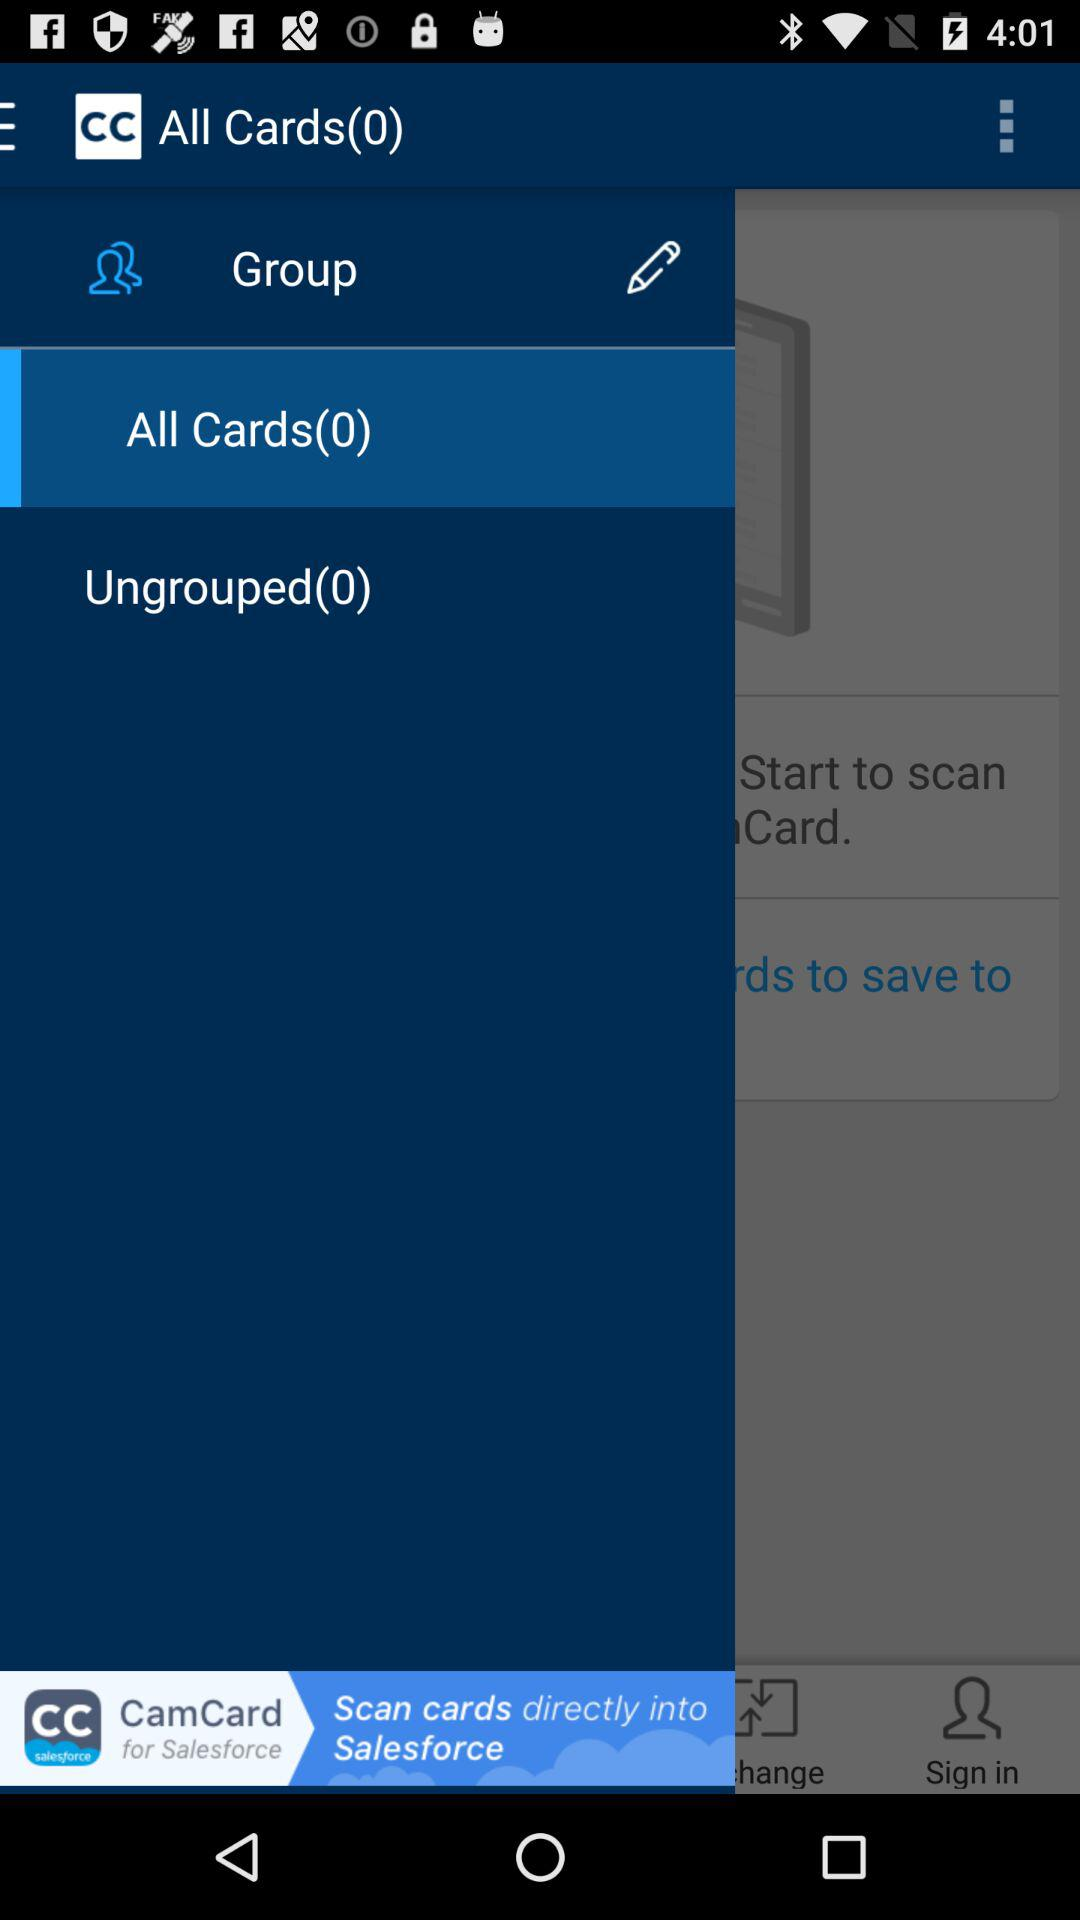How many ungrouped cards are there? There are 0 ungrouped cards. 